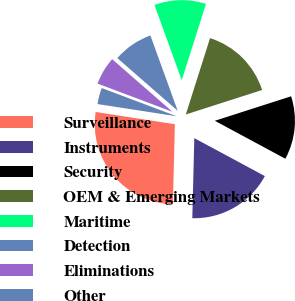<chart> <loc_0><loc_0><loc_500><loc_500><pie_chart><fcel>Surveillance<fcel>Instruments<fcel>Security<fcel>OEM & Emerging Markets<fcel>Maritime<fcel>Detection<fcel>Eliminations<fcel>Other<nl><fcel>27.04%<fcel>17.54%<fcel>12.8%<fcel>15.17%<fcel>10.42%<fcel>8.05%<fcel>5.68%<fcel>3.3%<nl></chart> 